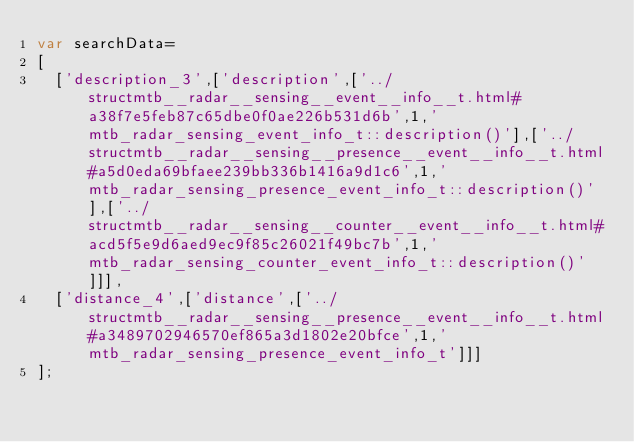<code> <loc_0><loc_0><loc_500><loc_500><_JavaScript_>var searchData=
[
  ['description_3',['description',['../structmtb__radar__sensing__event__info__t.html#a38f7e5feb87c65dbe0f0ae226b531d6b',1,'mtb_radar_sensing_event_info_t::description()'],['../structmtb__radar__sensing__presence__event__info__t.html#a5d0eda69bfaee239bb336b1416a9d1c6',1,'mtb_radar_sensing_presence_event_info_t::description()'],['../structmtb__radar__sensing__counter__event__info__t.html#acd5f5e9d6aed9ec9f85c26021f49bc7b',1,'mtb_radar_sensing_counter_event_info_t::description()']]],
  ['distance_4',['distance',['../structmtb__radar__sensing__presence__event__info__t.html#a3489702946570ef865a3d1802e20bfce',1,'mtb_radar_sensing_presence_event_info_t']]]
];
</code> 